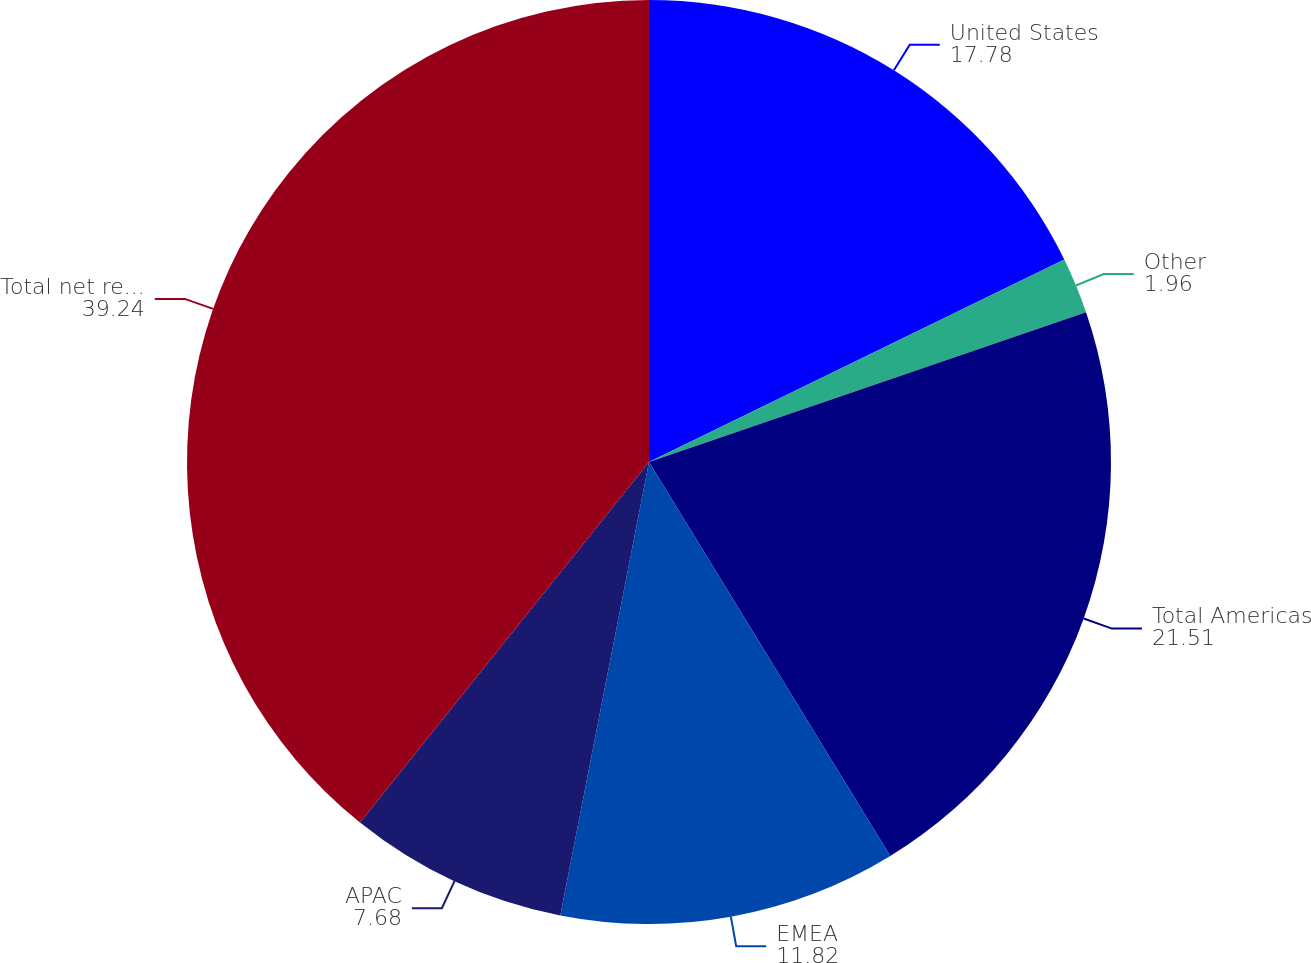<chart> <loc_0><loc_0><loc_500><loc_500><pie_chart><fcel>United States<fcel>Other<fcel>Total Americas<fcel>EMEA<fcel>APAC<fcel>Total net revenues<nl><fcel>17.78%<fcel>1.96%<fcel>21.51%<fcel>11.82%<fcel>7.68%<fcel>39.24%<nl></chart> 